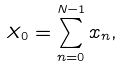<formula> <loc_0><loc_0><loc_500><loc_500>X _ { 0 } = \sum _ { n = 0 } ^ { N - 1 } x _ { n } ,</formula> 